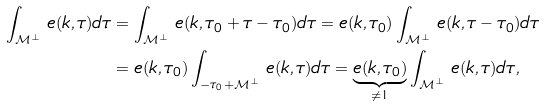<formula> <loc_0><loc_0><loc_500><loc_500>\int _ { \mathcal { M } ^ { \perp } } \, e ( k , \tau ) d \tau & = \int _ { \mathcal { M } ^ { \perp } } \, e ( k , \tau _ { 0 } + \tau - \tau _ { 0 } ) d \tau = e ( k , \tau _ { 0 } ) \int _ { \mathcal { M } ^ { \perp } } \, e ( k , \tau - \tau _ { 0 } ) d \tau \\ & = e ( k , \tau _ { 0 } ) \int _ { - \tau _ { 0 } + \mathcal { M } ^ { \perp } } \, e ( k , \tau ) d \tau = \underbrace { e ( k , \tau _ { 0 } ) } _ { \neq 1 } \int _ { \mathcal { M } ^ { \perp } } \, e ( k , \tau ) d \tau ,</formula> 